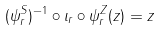<formula> <loc_0><loc_0><loc_500><loc_500>( \psi _ { r } ^ { S } ) ^ { - 1 } \circ \iota _ { r } \circ \psi _ { r } ^ { Z } ( z ) = z</formula> 